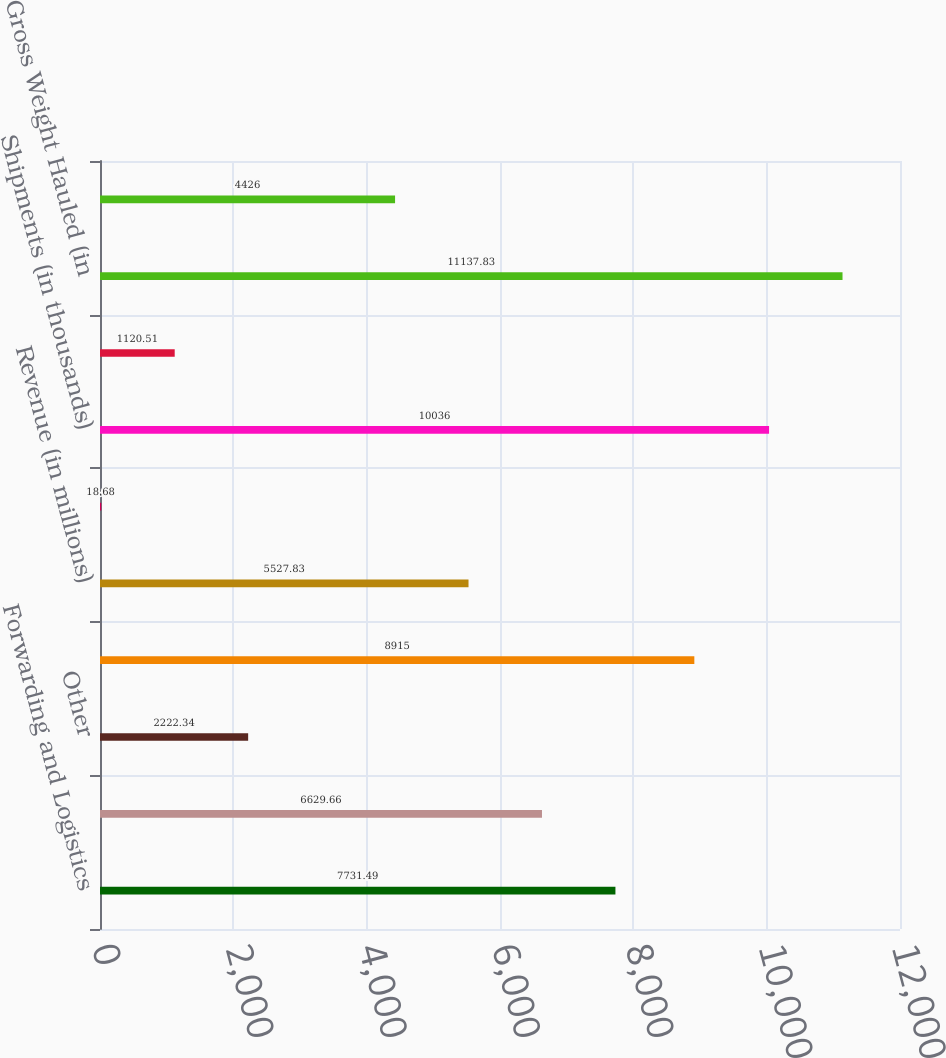Convert chart. <chart><loc_0><loc_0><loc_500><loc_500><bar_chart><fcel>Forwarding and Logistics<fcel>Freight<fcel>Other<fcel>Total Revenue<fcel>Revenue (in millions)<fcel>Revenue Per Hundredweight<fcel>Shipments (in thousands)<fcel>Shipments Per Day (in<fcel>Gross Weight Hauled (in<fcel>Weight Per Shipment (in lbs)<nl><fcel>7731.49<fcel>6629.66<fcel>2222.34<fcel>8915<fcel>5527.83<fcel>18.68<fcel>10036<fcel>1120.51<fcel>11137.8<fcel>4426<nl></chart> 